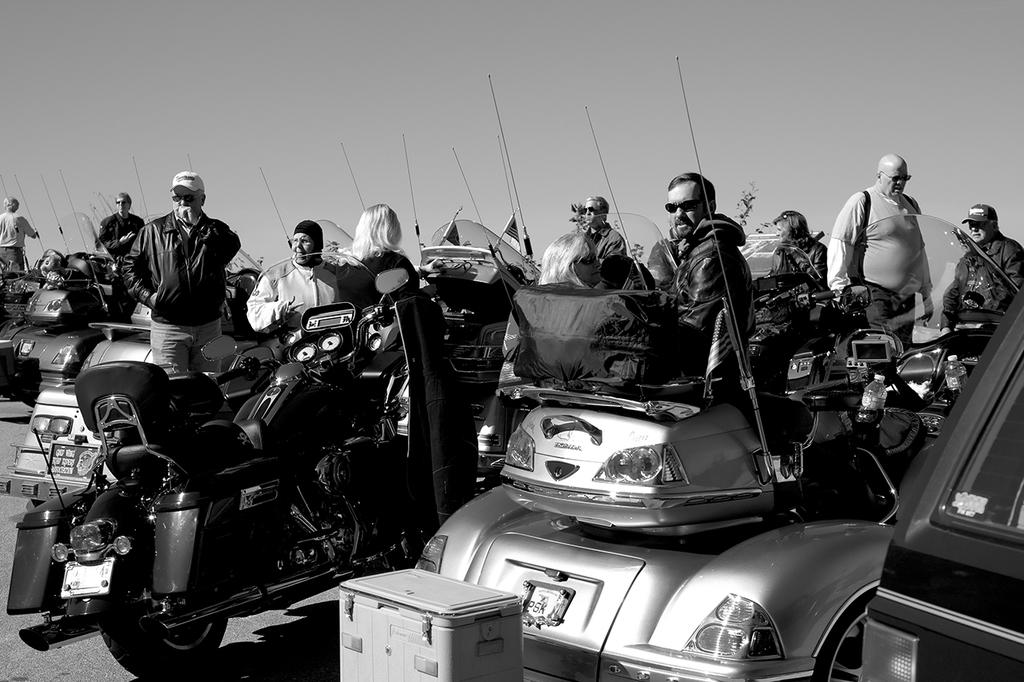What is happening in the image? There are people standing in the image. What can be seen beside the people? There are bikes parked beside the people. What type of property is visible on the moon in the image? There is no moon or property visible in the image; it only features people and bikes. 